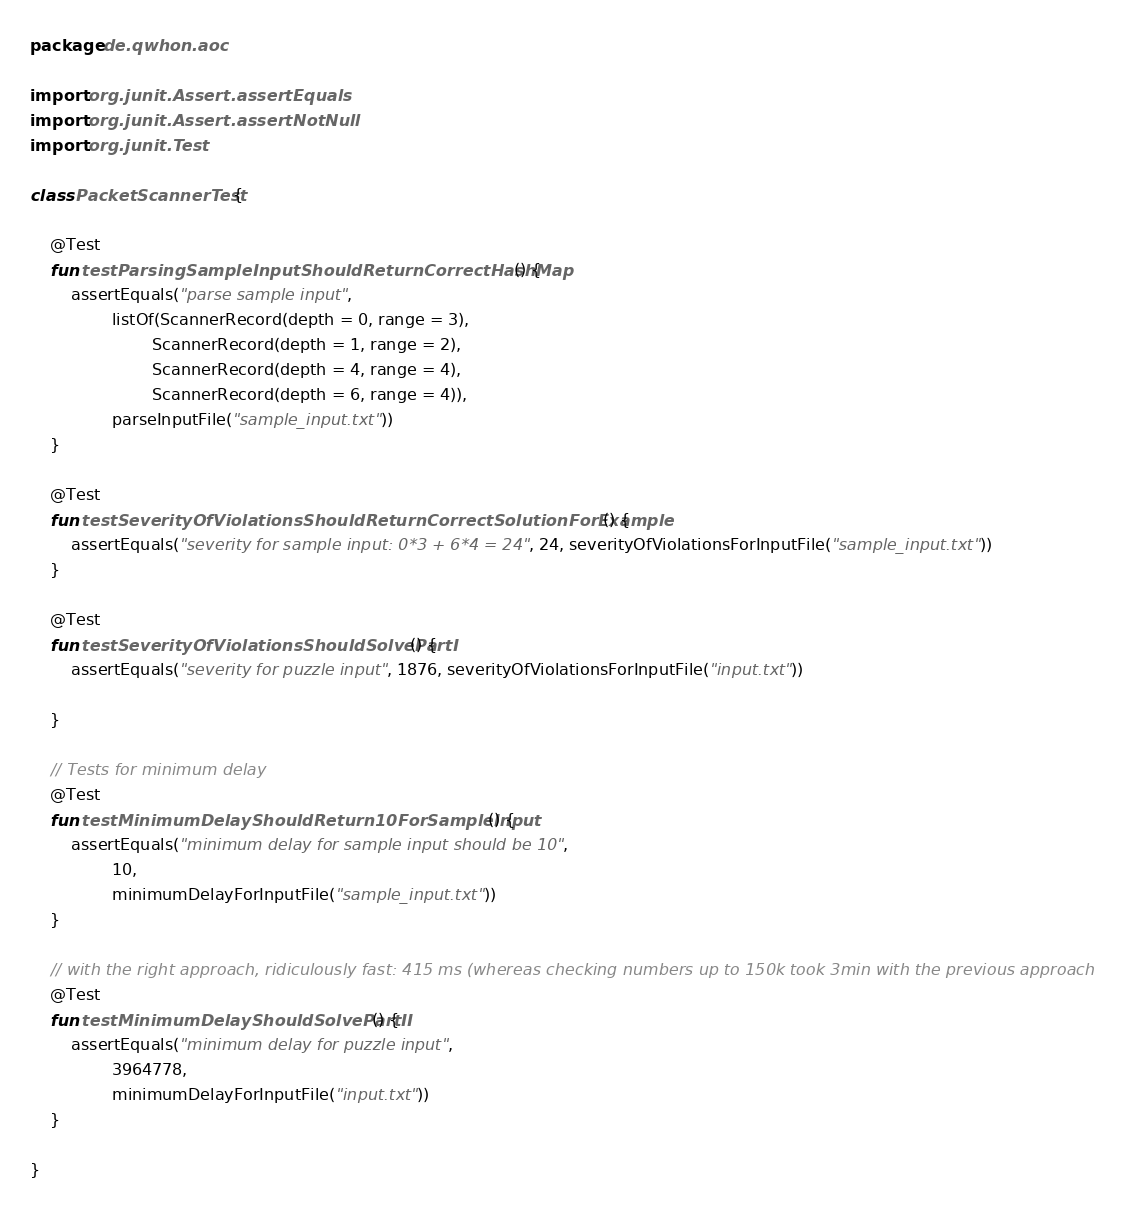<code> <loc_0><loc_0><loc_500><loc_500><_Kotlin_>package de.qwhon.aoc

import org.junit.Assert.assertEquals
import org.junit.Assert.assertNotNull
import org.junit.Test

class PacketScannerTest {

    @Test
    fun testParsingSampleInputShouldReturnCorrectHashMap() {
        assertEquals("parse sample input",
                listOf(ScannerRecord(depth = 0, range = 3),
                        ScannerRecord(depth = 1, range = 2),
                        ScannerRecord(depth = 4, range = 4),
                        ScannerRecord(depth = 6, range = 4)),
                parseInputFile("sample_input.txt"))
    }

    @Test
    fun testSeverityOfViolationsShouldReturnCorrectSolutionForExample() {
        assertEquals("severity for sample input: 0*3 + 6*4 = 24", 24, severityOfViolationsForInputFile("sample_input.txt"))
    }

    @Test
    fun testSeverityOfViolationsShouldSolvePartI() {
        assertEquals("severity for puzzle input", 1876, severityOfViolationsForInputFile("input.txt"))

    }

    // Tests for minimum delay
    @Test
    fun testMinimumDelayShouldReturn10ForSampleInput() {
        assertEquals("minimum delay for sample input should be 10",
                10,
                minimumDelayForInputFile("sample_input.txt"))
    }

    // with the right approach, ridiculously fast: 415 ms (whereas checking numbers up to 150k took 3min with the previous approach
    @Test
    fun testMinimumDelayShouldSolvePartII() {
        assertEquals("minimum delay for puzzle input",
                3964778,
                minimumDelayForInputFile("input.txt"))
    }

}
</code> 